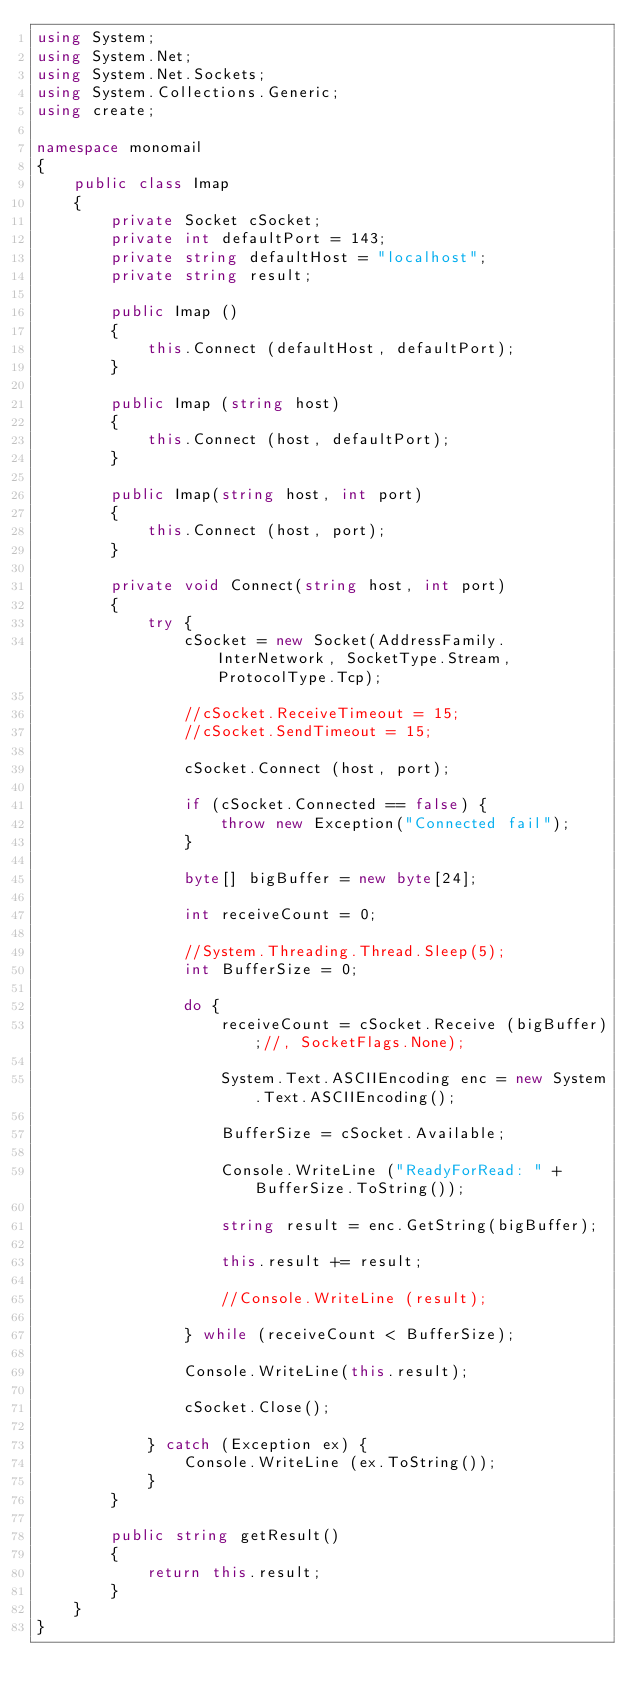Convert code to text. <code><loc_0><loc_0><loc_500><loc_500><_C#_>using System;
using System.Net;
using System.Net.Sockets;
using System.Collections.Generic;
using create;

namespace monomail
{
	public class Imap
	{
		private Socket cSocket;
		private int defaultPort = 143;
		private string defaultHost = "localhost";
		private string result;

		public Imap ()
		{
			this.Connect (defaultHost, defaultPort);
		}

		public Imap (string host)
		{
			this.Connect (host, defaultPort);
		}

		public Imap(string host, int port)
		{
			this.Connect (host, port);
		}

		private void Connect(string host, int port)
		{
			try {
				cSocket = new Socket(AddressFamily.InterNetwork, SocketType.Stream, ProtocolType.Tcp);

				//cSocket.ReceiveTimeout = 15;
				//cSocket.SendTimeout = 15;

				cSocket.Connect (host, port);

				if (cSocket.Connected == false) {
					throw new Exception("Connected fail");
				}

				byte[] bigBuffer = new byte[24];

				int receiveCount = 0;

				//System.Threading.Thread.Sleep(5);
				int BufferSize = 0;

				do {
					receiveCount = cSocket.Receive (bigBuffer);//, SocketFlags.None);

					System.Text.ASCIIEncoding enc = new System.Text.ASCIIEncoding();

					BufferSize = cSocket.Available;

					Console.WriteLine ("ReadyForRead: " + BufferSize.ToString());

					string result = enc.GetString(bigBuffer);

					this.result += result;

					//Console.WriteLine (result);

				} while (receiveCount < BufferSize);

				Console.WriteLine(this.result);

				cSocket.Close();

			} catch (Exception ex) {
				Console.WriteLine (ex.ToString());
			}
		}

		public string getResult()
		{
			return this.result;
		}
	}
}

</code> 